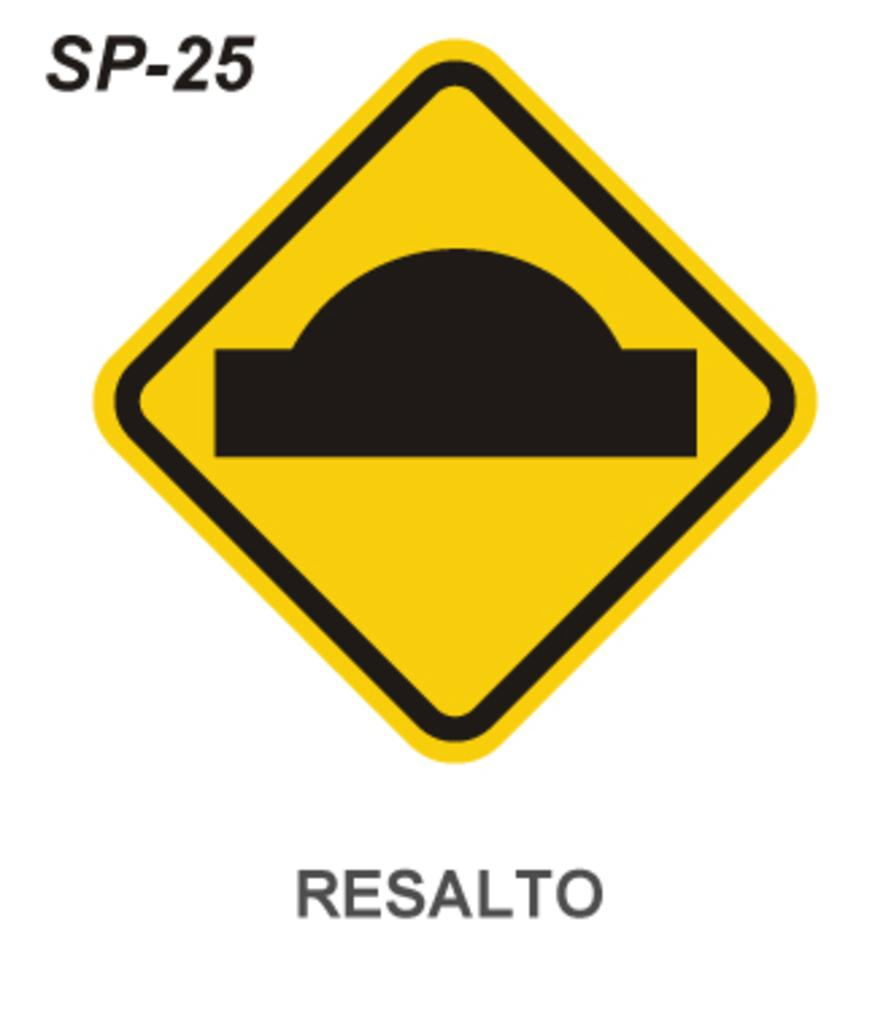<image>
Describe the image concisely. SP-25 Resalto is labeled on this speed bump warning sign. 